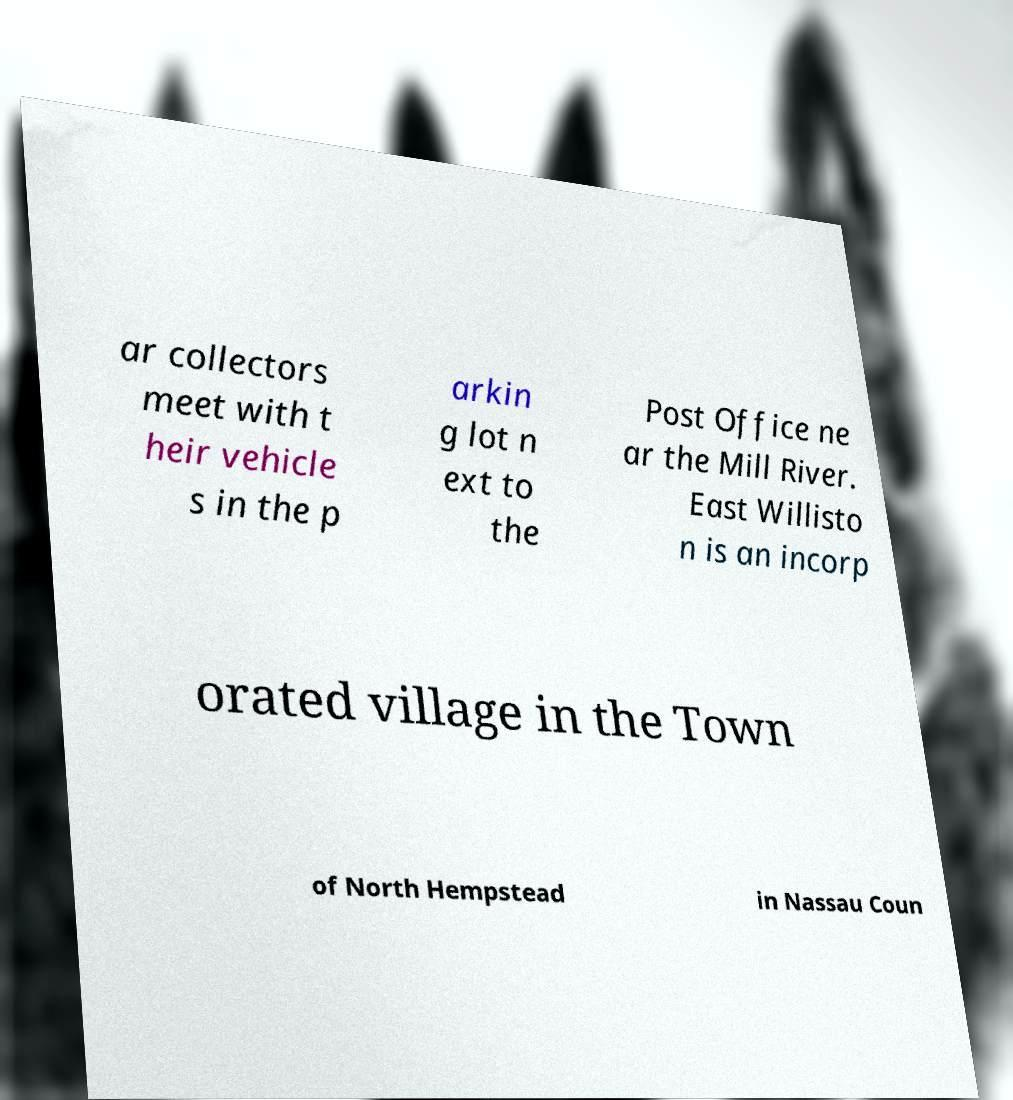I need the written content from this picture converted into text. Can you do that? ar collectors meet with t heir vehicle s in the p arkin g lot n ext to the Post Office ne ar the Mill River. East Willisto n is an incorp orated village in the Town of North Hempstead in Nassau Coun 